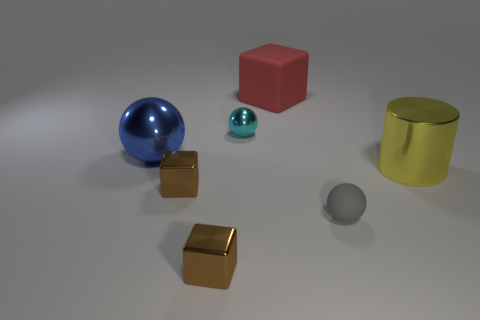What number of metallic things are either big cylinders or spheres?
Make the answer very short. 3. What is the size of the sphere that is in front of the big cylinder?
Make the answer very short. Small. What is the size of the cyan thing that is made of the same material as the big cylinder?
Keep it short and to the point. Small. Is there a large purple object?
Give a very brief answer. No. There is a small gray matte thing; is its shape the same as the big blue object behind the small gray object?
Ensure brevity in your answer.  Yes. What is the color of the big metallic object that is to the right of the brown block that is in front of the shiny cube that is behind the small rubber sphere?
Make the answer very short. Yellow. There is a large blue metallic ball; are there any blue spheres to the left of it?
Provide a succinct answer. No. Are there any yellow objects that have the same material as the red block?
Offer a very short reply. No. The rubber block is what color?
Make the answer very short. Red. Is the shape of the tiny thing that is right of the large red cube the same as  the small cyan metal object?
Your answer should be very brief. Yes. 